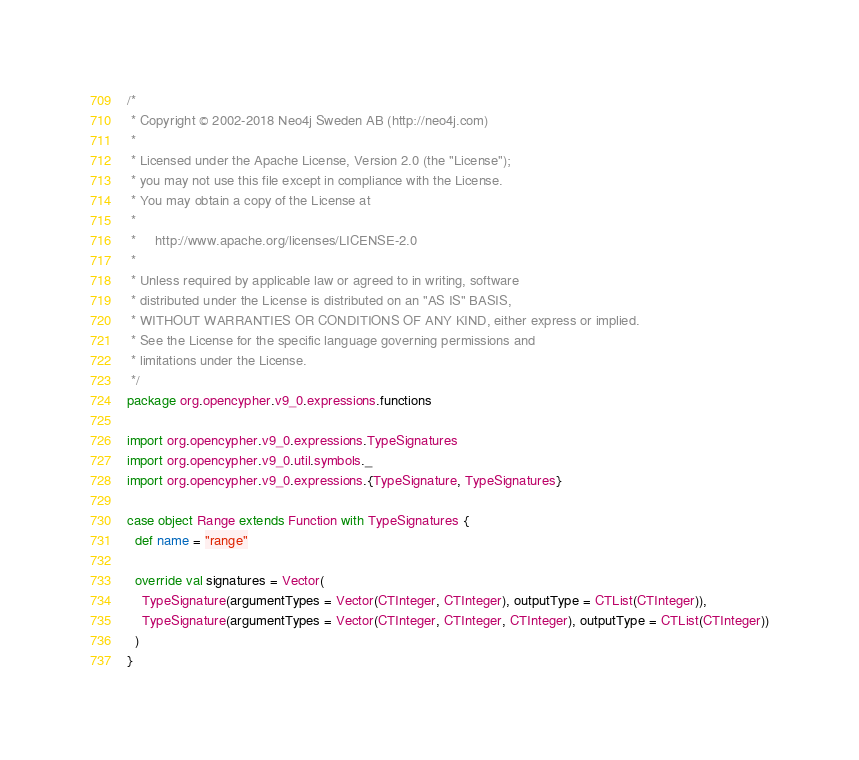Convert code to text. <code><loc_0><loc_0><loc_500><loc_500><_Scala_>/*
 * Copyright © 2002-2018 Neo4j Sweden AB (http://neo4j.com)
 *
 * Licensed under the Apache License, Version 2.0 (the "License");
 * you may not use this file except in compliance with the License.
 * You may obtain a copy of the License at
 *
 *     http://www.apache.org/licenses/LICENSE-2.0
 *
 * Unless required by applicable law or agreed to in writing, software
 * distributed under the License is distributed on an "AS IS" BASIS,
 * WITHOUT WARRANTIES OR CONDITIONS OF ANY KIND, either express or implied.
 * See the License for the specific language governing permissions and
 * limitations under the License.
 */
package org.opencypher.v9_0.expressions.functions

import org.opencypher.v9_0.expressions.TypeSignatures
import org.opencypher.v9_0.util.symbols._
import org.opencypher.v9_0.expressions.{TypeSignature, TypeSignatures}

case object Range extends Function with TypeSignatures {
  def name = "range"

  override val signatures = Vector(
    TypeSignature(argumentTypes = Vector(CTInteger, CTInteger), outputType = CTList(CTInteger)),
    TypeSignature(argumentTypes = Vector(CTInteger, CTInteger, CTInteger), outputType = CTList(CTInteger))
  )
}
</code> 